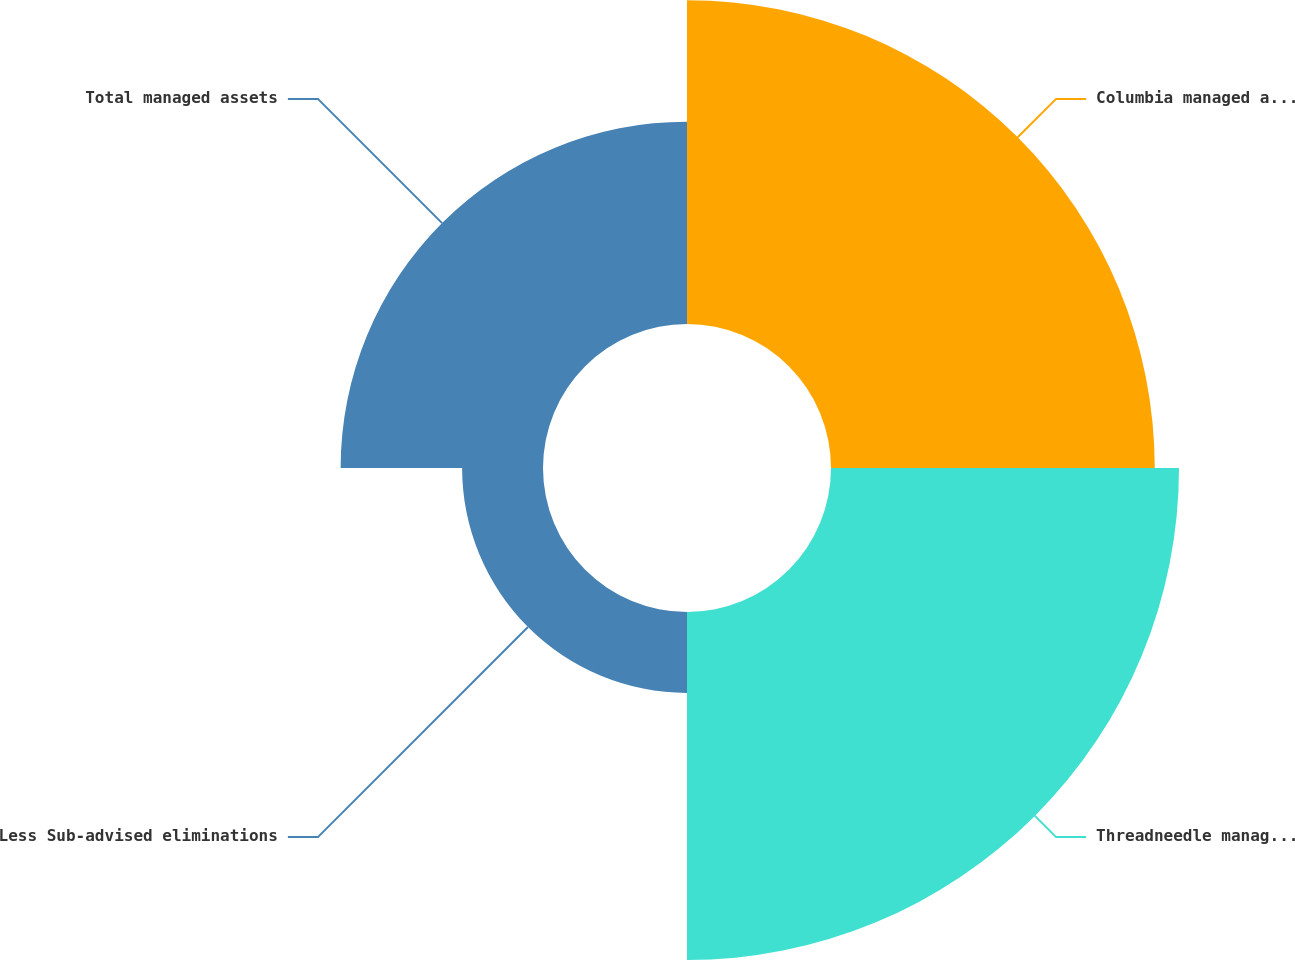<chart> <loc_0><loc_0><loc_500><loc_500><pie_chart><fcel>Columbia managed assets<fcel>Threadneedle managed assets<fcel>Less Sub-advised eliminations<fcel>Total managed assets<nl><fcel>33.9%<fcel>36.44%<fcel>8.47%<fcel>21.19%<nl></chart> 